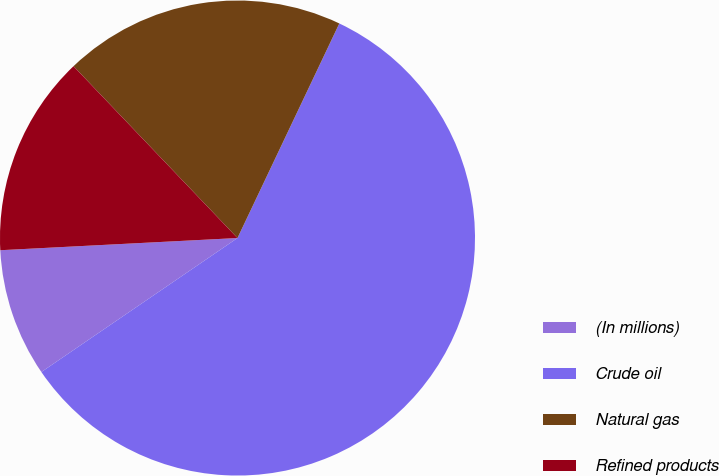Convert chart to OTSL. <chart><loc_0><loc_0><loc_500><loc_500><pie_chart><fcel>(In millions)<fcel>Crude oil<fcel>Natural gas<fcel>Refined products<nl><fcel>8.72%<fcel>58.41%<fcel>19.18%<fcel>13.69%<nl></chart> 